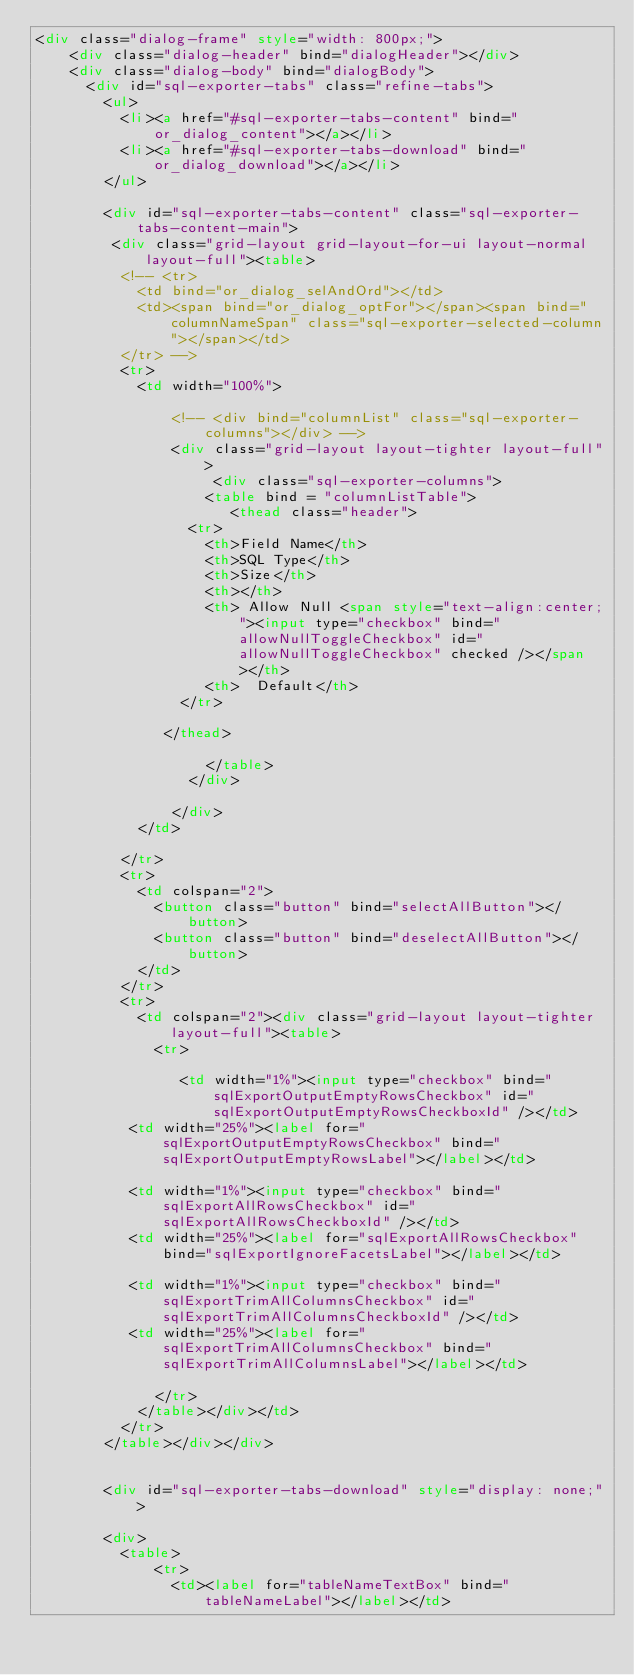<code> <loc_0><loc_0><loc_500><loc_500><_HTML_><div class="dialog-frame" style="width: 800px;">
    <div class="dialog-header" bind="dialogHeader"></div>
    <div class="dialog-body" bind="dialogBody">
      <div id="sql-exporter-tabs" class="refine-tabs">
        <ul>
          <li><a href="#sql-exporter-tabs-content" bind="or_dialog_content"></a></li>
          <li><a href="#sql-exporter-tabs-download" bind="or_dialog_download"></a></li>
        </ul>
        
        <div id="sql-exporter-tabs-content" class="sql-exporter-tabs-content-main">
         <div class="grid-layout grid-layout-for-ui layout-normal layout-full"><table>
          <!-- <tr>
            <td bind="or_dialog_selAndOrd"></td>
            <td><span bind="or_dialog_optFor"></span><span bind="columnNameSpan" class="sql-exporter-selected-column"></span></td>
          </tr> -->
          <tr>
            <td width="100%">
            	
                <!-- <div bind="columnList" class="sql-exporter-columns"></div> -->
                <div class="grid-layout layout-tighter layout-full">
                     <div class="sql-exporter-columns">
	            			<table bind = "columnListTable">
	            				 <thead class="header">
							    <tr>
							      <th>Field Name</th>
							      <th>SQL Type</th>
							      <th>Size</th>
							      <th></th>
							      <th> Allow Null <span style="text-align:center;"><input type="checkbox" bind="allowNullToggleCheckbox" id="allowNullToggleCheckbox" checked /></span></th>
							      <th>  Default</th>
							   </tr>
						
							 </thead>
	            				
	            			</table>
	            		</div>
	            		
            		</div>
            </td>
         
          </tr>
          <tr>
            <td colspan="2">
              <button class="button" bind="selectAllButton"></button>
              <button class="button" bind="deselectAllButton"></button>
            </td>
          </tr>
          <tr>
            <td colspan="2"><div class="grid-layout layout-tighter layout-full"><table>
              <tr>
          
                 <td width="1%"><input type="checkbox" bind="sqlExportOutputEmptyRowsCheckbox" id="sqlExportOutputEmptyRowsCheckboxId" /></td>
			     <td width="25%"><label for="sqlExportOutputEmptyRowsCheckbox" bind="sqlExportOutputEmptyRowsLabel"></label></td>
			  
			     <td width="1%"><input type="checkbox" bind="sqlExportAllRowsCheckbox" id="sqlExportAllRowsCheckboxId" /></td>
			     <td width="25%"><label for="sqlExportAllRowsCheckbox" bind="sqlExportIgnoreFacetsLabel"></label></td>
			     
			     <td width="1%"><input type="checkbox" bind="sqlExportTrimAllColumnsCheckbox" id="sqlExportTrimAllColumnsCheckboxId" /></td>
			     <td width="25%"><label for="sqlExportTrimAllColumnsCheckbox" bind="sqlExportTrimAllColumnsLabel"></label></td>
                
              </tr>
            </table></div></td>
          </tr>
        </table></div></div>
        
        
        <div id="sql-exporter-tabs-download" style="display: none;">
        
        <div>
	        <table>
	        	  <tr>
		           	<td><label for="tableNameTextBox" bind="tableNameLabel"></label></td></code> 